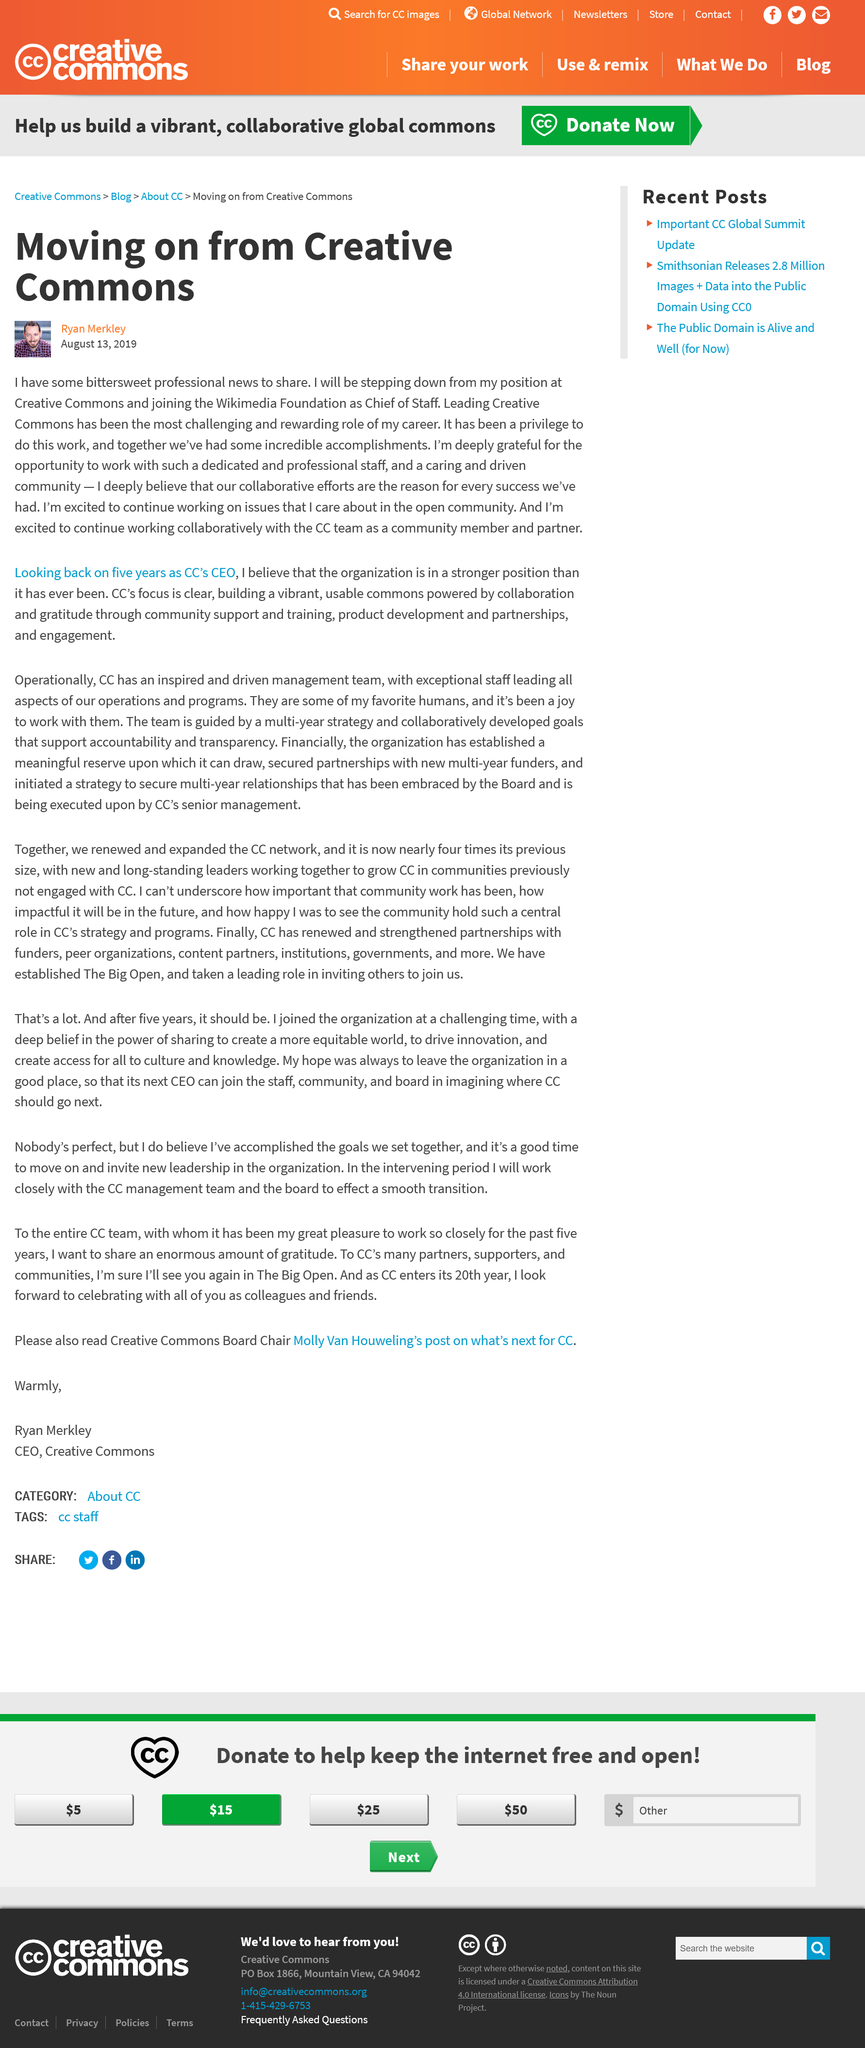Identify some key points in this picture. Ryan Merkley is the author of this article. As of February 14th, 2023, it has been announced that Larry Lessig will be stepping down from his position as the President and CEO of Creative Commons. This article was written on August 13, 2019, as declared in the text. 